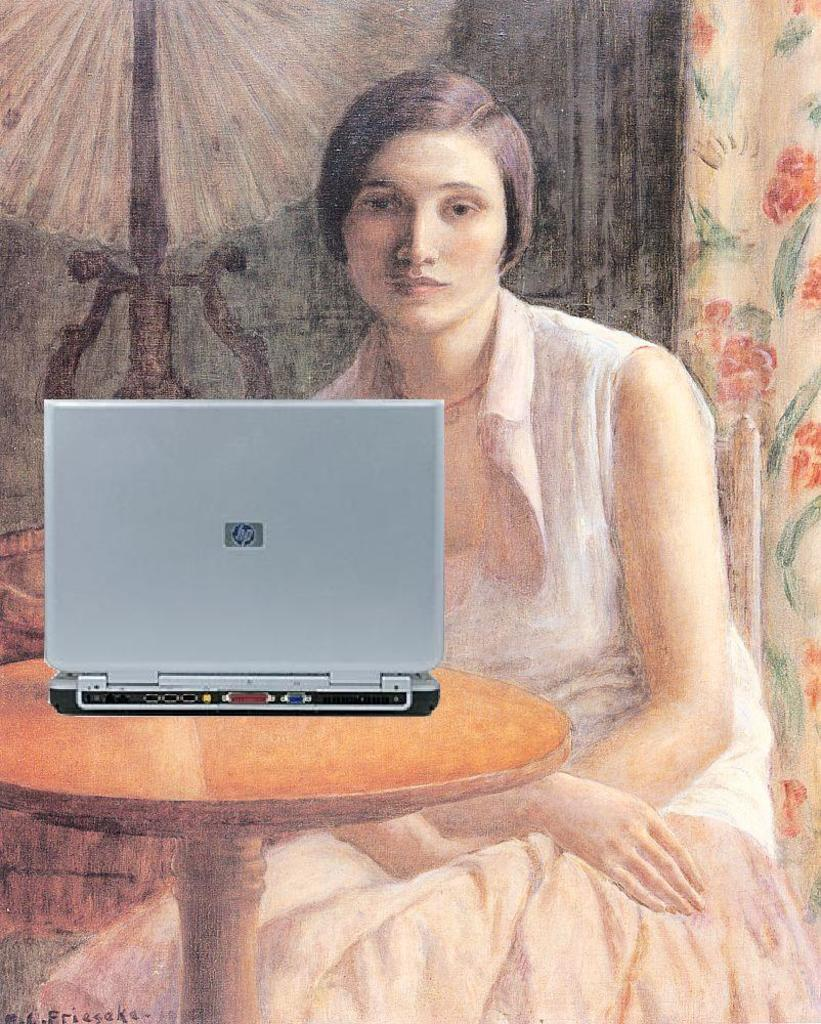What is the woman doing in the painting? The painting depicts a woman sitting. What is in front of the woman? There is a table in front of the woman. What object is on the table? A laptop is present on the table. What can be seen behind the woman? There is a curtain behind the woman. What light source is visible in the scene? A lamp is present in the scene. What type of silk material is draped over the woman's bed in the painting? There is no bed or silk material present in the painting; it features a woman sitting with a table, laptop, curtain, and lamp. 